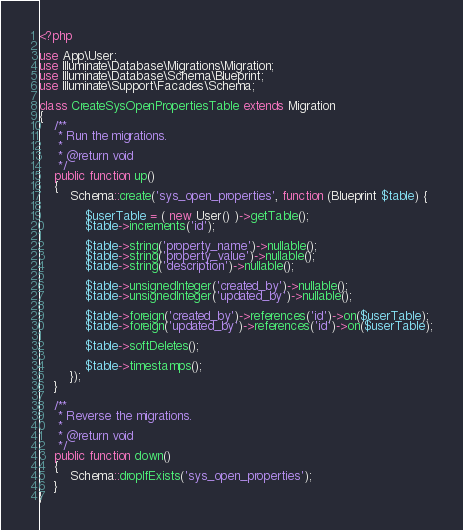Convert code to text. <code><loc_0><loc_0><loc_500><loc_500><_PHP_><?php

use App\User;
use Illuminate\Database\Migrations\Migration;
use Illuminate\Database\Schema\Blueprint;
use Illuminate\Support\Facades\Schema;

class CreateSysOpenPropertiesTable extends Migration
{
    /**
     * Run the migrations.
     *
     * @return void
     */
    public function up()
    {
        Schema::create('sys_open_properties', function (Blueprint $table) {

            $userTable = ( new User() )->getTable();
            $table->increments('id');

            $table->string('property_name')->nullable();
            $table->string('property_value')->nullable();
            $table->string('description')->nullable();

            $table->unsignedInteger('created_by')->nullable();
            $table->unsignedInteger('updated_by')->nullable();

            $table->foreign('created_by')->references('id')->on($userTable);
            $table->foreign('updated_by')->references('id')->on($userTable);

            $table->softDeletes();

            $table->timestamps();
        });
    }

    /**
     * Reverse the migrations.
     *
     * @return void
     */
    public function down()
    {
        Schema::dropIfExists('sys_open_properties');
    }
}
</code> 